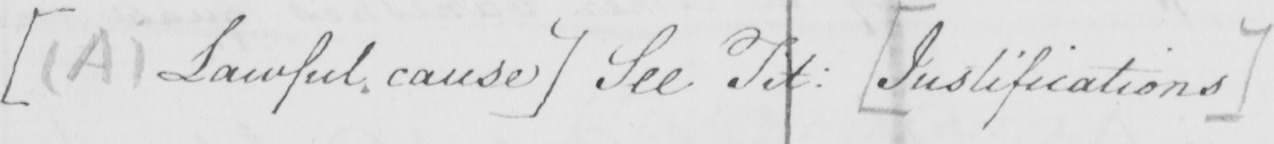Please transcribe the handwritten text in this image. [  ( A )  Lawful cause ]  See Tit :   [ Justifications ] 